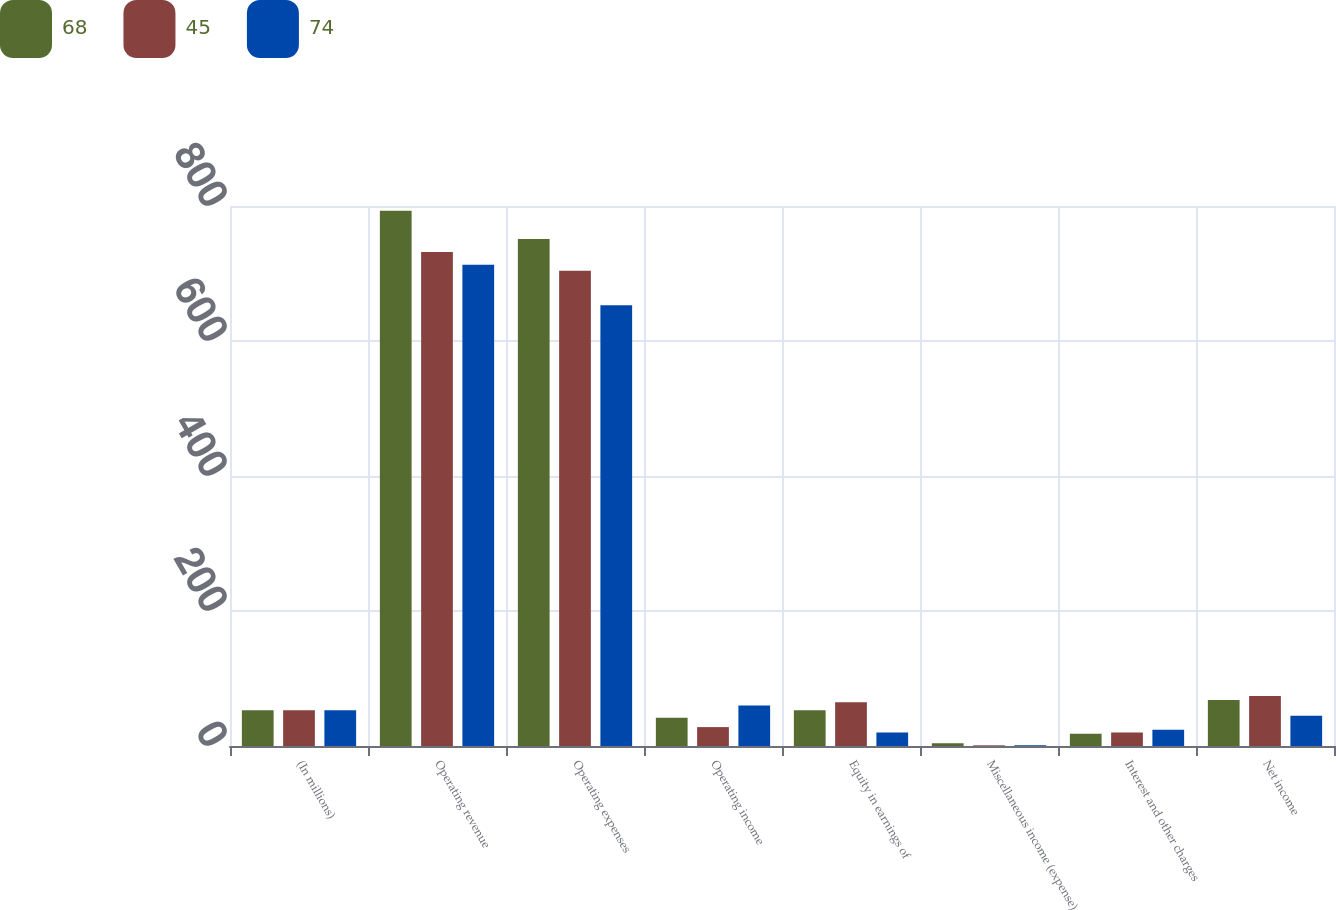<chart> <loc_0><loc_0><loc_500><loc_500><stacked_bar_chart><ecel><fcel>(In millions)<fcel>Operating revenue<fcel>Operating expenses<fcel>Operating income<fcel>Equity in earnings of<fcel>Miscellaneous income (expense)<fcel>Interest and other charges<fcel>Net income<nl><fcel>68<fcel>53<fcel>793<fcel>751<fcel>42<fcel>53<fcel>4<fcel>18<fcel>68<nl><fcel>45<fcel>53<fcel>732<fcel>704<fcel>28<fcel>65<fcel>1<fcel>20<fcel>74<nl><fcel>74<fcel>53<fcel>713<fcel>653<fcel>60<fcel>20<fcel>1<fcel>24<fcel>45<nl></chart> 